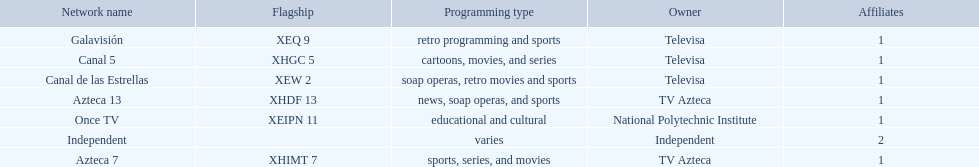What television stations are in morelos? Canal de las Estrellas, Canal 5, Azteca 7, Galavisión, Once TV, Azteca 13, Independent. Of those which network is owned by national polytechnic institute? Once TV. 